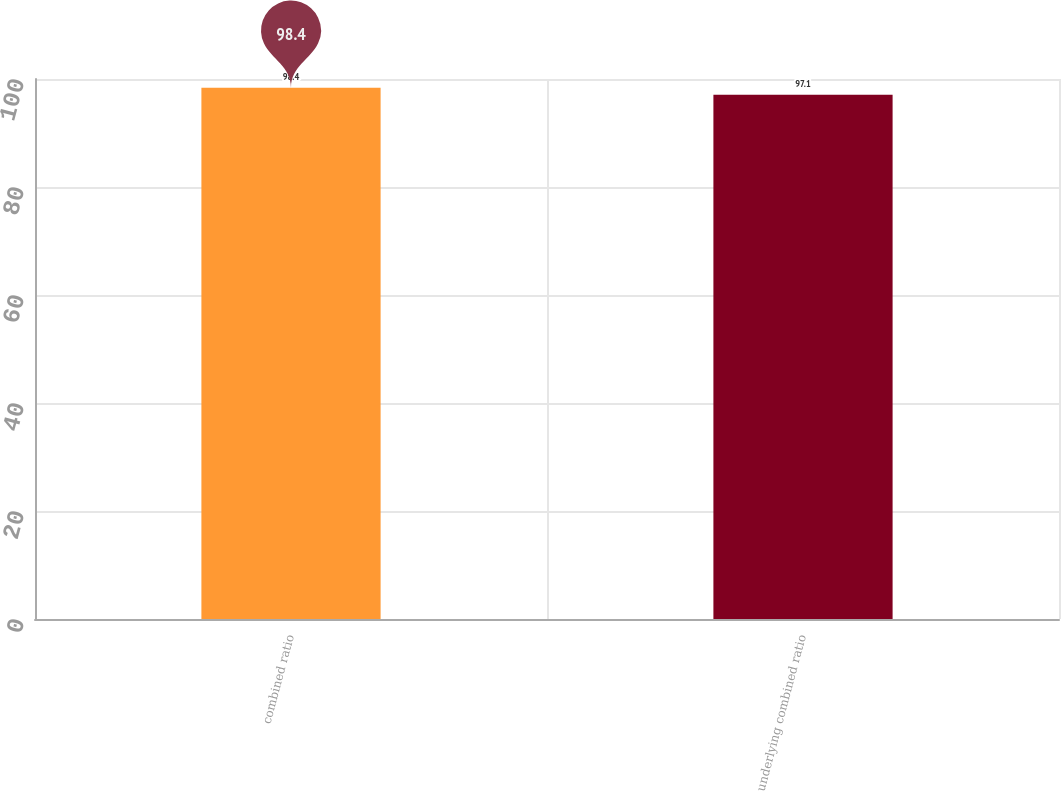Convert chart. <chart><loc_0><loc_0><loc_500><loc_500><bar_chart><fcel>combined ratio<fcel>underlying combined ratio<nl><fcel>98.4<fcel>97.1<nl></chart> 